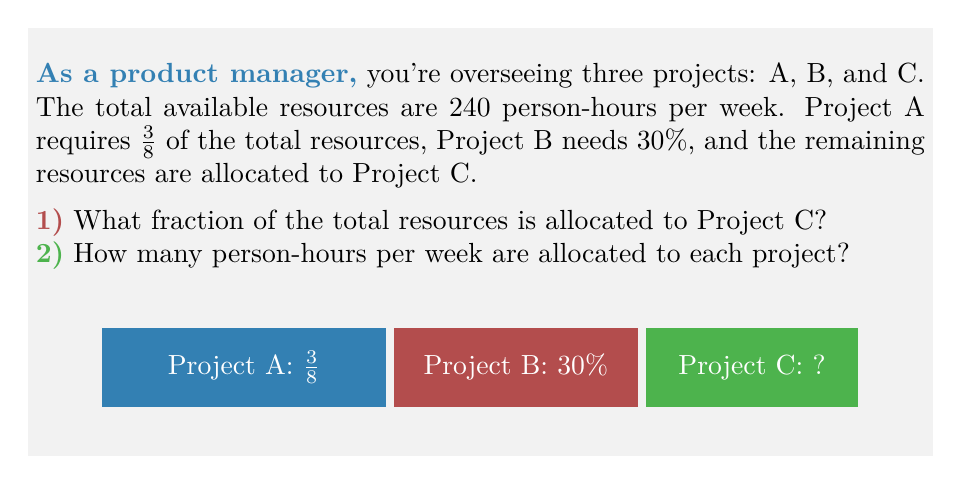Show me your answer to this math problem. Let's approach this step-by-step:

1) To find the fraction of resources allocated to Project C:
   - Project A uses $\frac{3}{8}$ of resources
   - Project B uses $30\% = \frac{30}{100} = \frac{3}{10}$ of resources
   - The remaining fraction for Project C is:
     $$1 - (\frac{3}{8} + \frac{3}{10}) = 1 - (\frac{15}{40} + \frac{12}{40}) = 1 - \frac{27}{40} = \frac{13}{40}$$

2) To calculate person-hours per week for each project:
   - Total resources: 240 person-hours per week
   - Project A: $\frac{3}{8} \times 240 = 90$ person-hours
   - Project B: $30\% \times 240 = 0.3 \times 240 = 72$ person-hours
   - Project C: $\frac{13}{40} \times 240 = 78$ person-hours

   We can verify: $90 + 72 + 78 = 240$ person-hours (total resources)
Answer: 1) $\frac{13}{40}$
2) A: 90, B: 72, C: 78 person-hours 